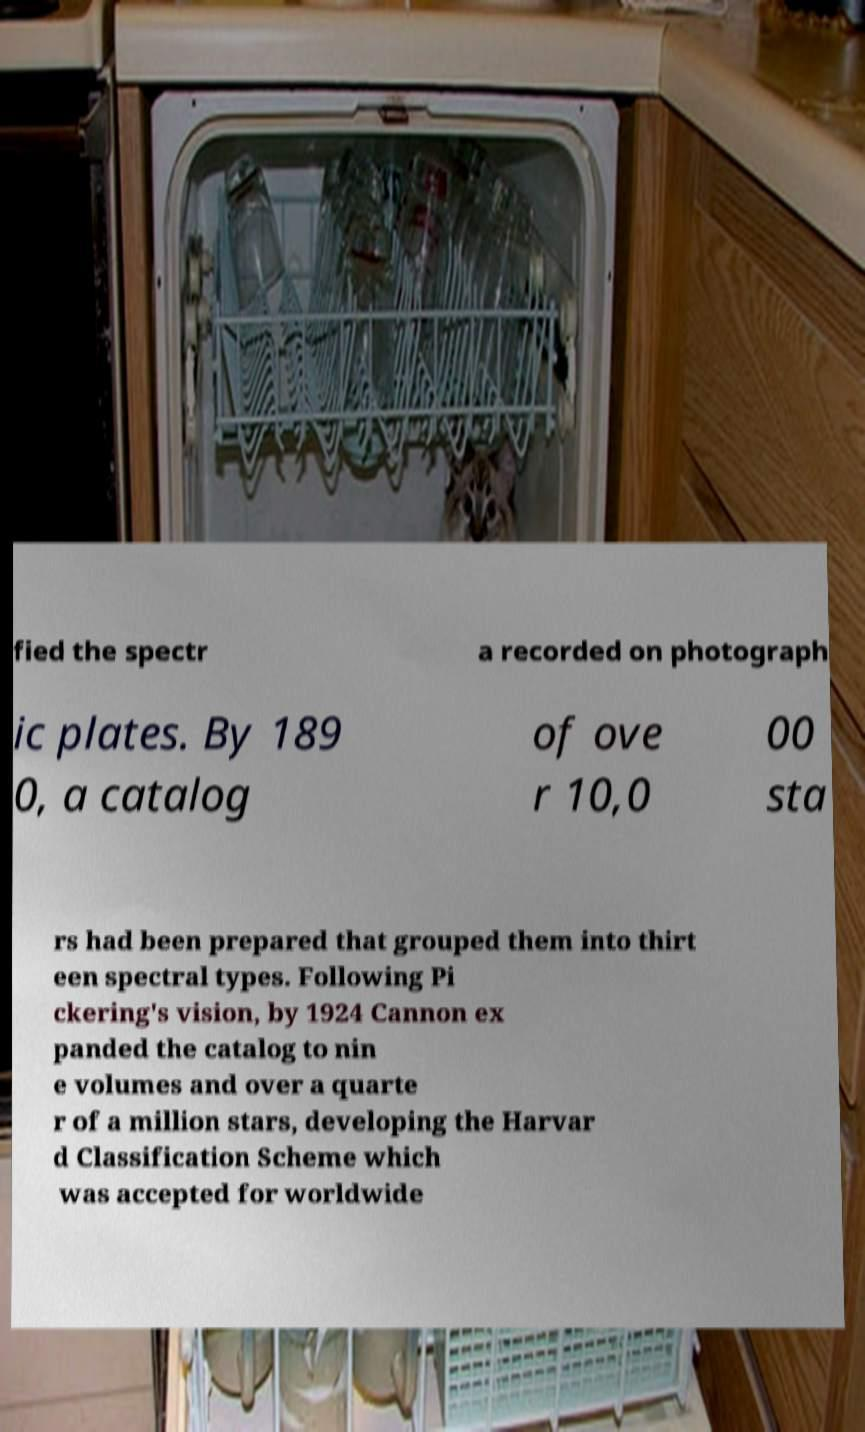What messages or text are displayed in this image? I need them in a readable, typed format. fied the spectr a recorded on photograph ic plates. By 189 0, a catalog of ove r 10,0 00 sta rs had been prepared that grouped them into thirt een spectral types. Following Pi ckering's vision, by 1924 Cannon ex panded the catalog to nin e volumes and over a quarte r of a million stars, developing the Harvar d Classification Scheme which was accepted for worldwide 